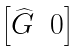Convert formula to latex. <formula><loc_0><loc_0><loc_500><loc_500>\begin{bmatrix} \widehat { G } & 0 \end{bmatrix}</formula> 